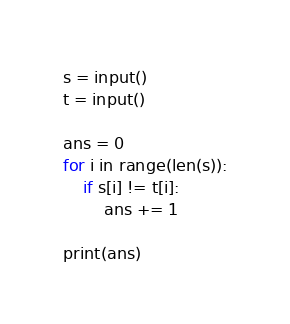<code> <loc_0><loc_0><loc_500><loc_500><_Python_>s = input()
t = input()

ans = 0
for i in range(len(s)):
    if s[i] != t[i]:
        ans += 1

print(ans)</code> 